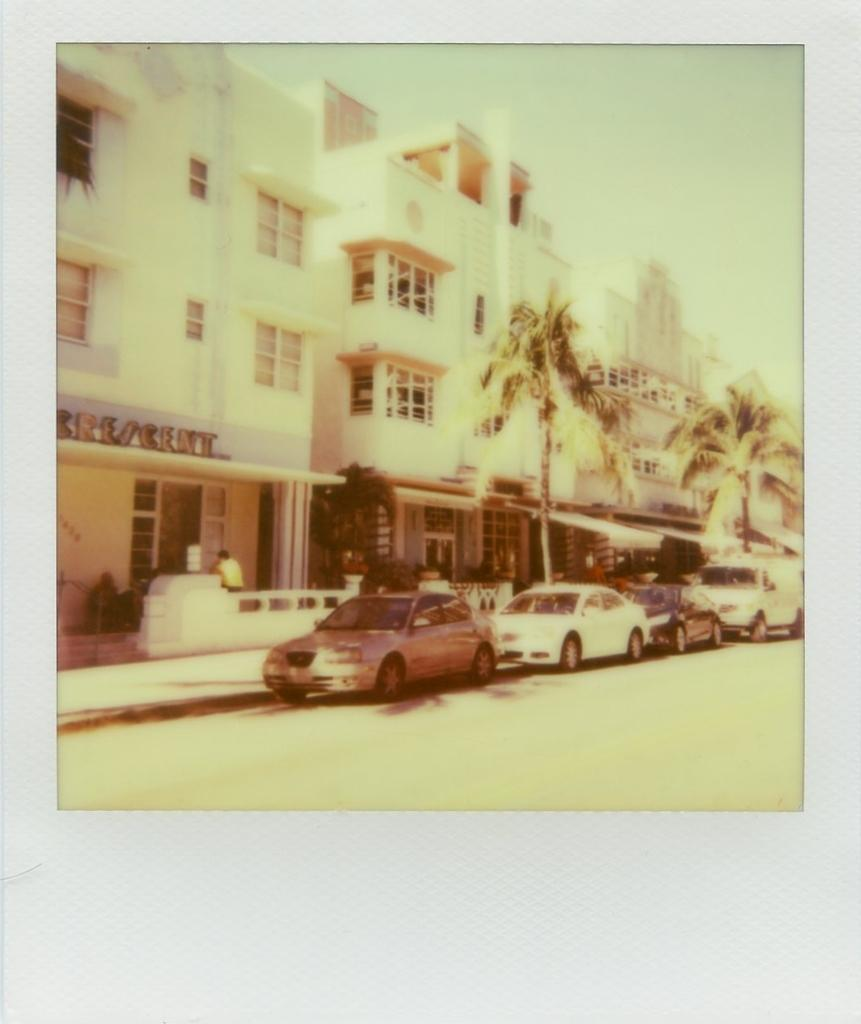What type of natural elements can be seen in the image? There are trees in the image. What type of man-made structures are present in the image? There are buildings in the image. What type of transportation is visible in the image? There are cars in the image. What is the primary pathway for vehicles in the image? There is a road in the image. What can be seen in the background of the image? The sky is visible in the background of the image. What type of bead is used to decorate the arch in the image? There is no arch or bead present in the image. What type of trade is being conducted in the image? There is no trade or indication of any economic activity in the image. 